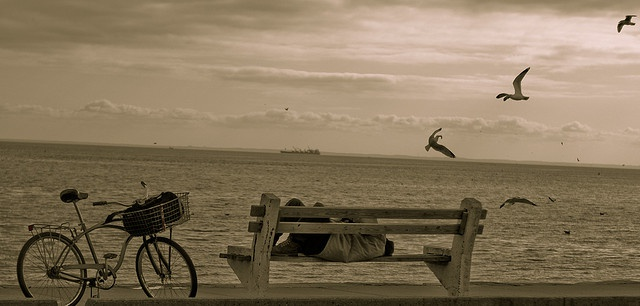Describe the objects in this image and their specific colors. I can see bench in gray, black, and darkgreen tones, bicycle in gray and black tones, people in gray, black, and darkgreen tones, backpack in gray, black, and darkgreen tones, and handbag in gray, black, and darkgreen tones in this image. 